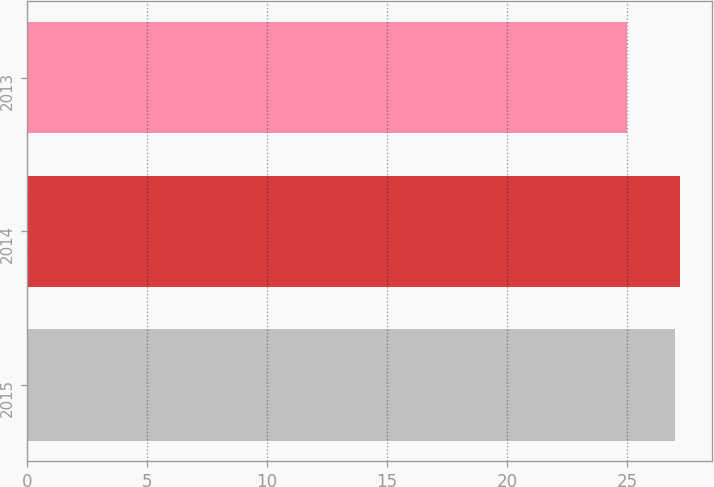<chart> <loc_0><loc_0><loc_500><loc_500><bar_chart><fcel>2015<fcel>2014<fcel>2013<nl><fcel>27<fcel>27.2<fcel>25<nl></chart> 